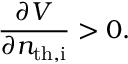<formula> <loc_0><loc_0><loc_500><loc_500>\frac { \partial V } { \partial n _ { t h , i } } > 0 .</formula> 